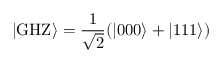Convert formula to latex. <formula><loc_0><loc_0><loc_500><loc_500>| G H Z \rangle = \frac { 1 } { \sqrt { 2 } } ( | 0 0 0 \rangle + | 1 1 1 \rangle )</formula> 